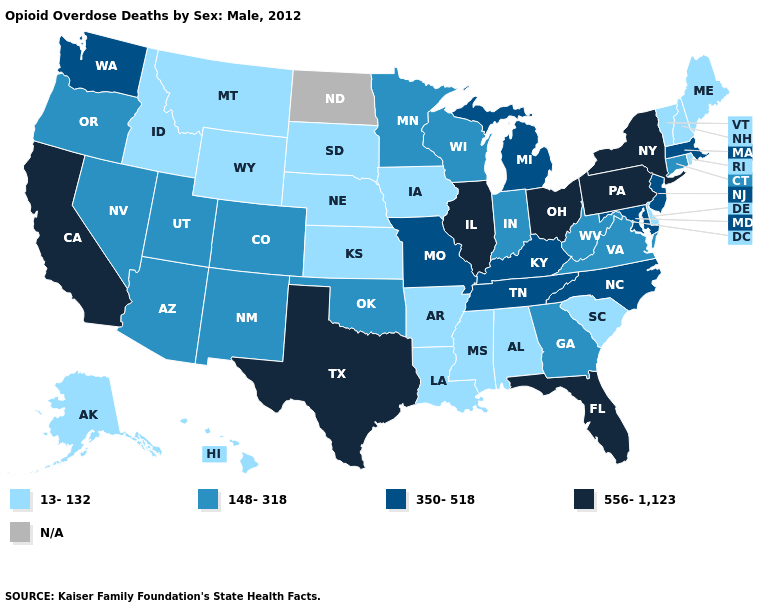Among the states that border Pennsylvania , which have the highest value?
Give a very brief answer. New York, Ohio. Name the states that have a value in the range 13-132?
Be succinct. Alabama, Alaska, Arkansas, Delaware, Hawaii, Idaho, Iowa, Kansas, Louisiana, Maine, Mississippi, Montana, Nebraska, New Hampshire, Rhode Island, South Carolina, South Dakota, Vermont, Wyoming. Does the map have missing data?
Answer briefly. Yes. What is the value of Michigan?
Short answer required. 350-518. Does Rhode Island have the highest value in the Northeast?
Answer briefly. No. What is the lowest value in states that border Mississippi?
Concise answer only. 13-132. Does the map have missing data?
Quick response, please. Yes. Does Vermont have the highest value in the USA?
Write a very short answer. No. Name the states that have a value in the range 556-1,123?
Be succinct. California, Florida, Illinois, New York, Ohio, Pennsylvania, Texas. Does Florida have the lowest value in the USA?
Write a very short answer. No. Which states hav the highest value in the West?
Write a very short answer. California. What is the highest value in states that border Arkansas?
Answer briefly. 556-1,123. What is the value of Vermont?
Answer briefly. 13-132. Which states have the lowest value in the USA?
Be succinct. Alabama, Alaska, Arkansas, Delaware, Hawaii, Idaho, Iowa, Kansas, Louisiana, Maine, Mississippi, Montana, Nebraska, New Hampshire, Rhode Island, South Carolina, South Dakota, Vermont, Wyoming. 